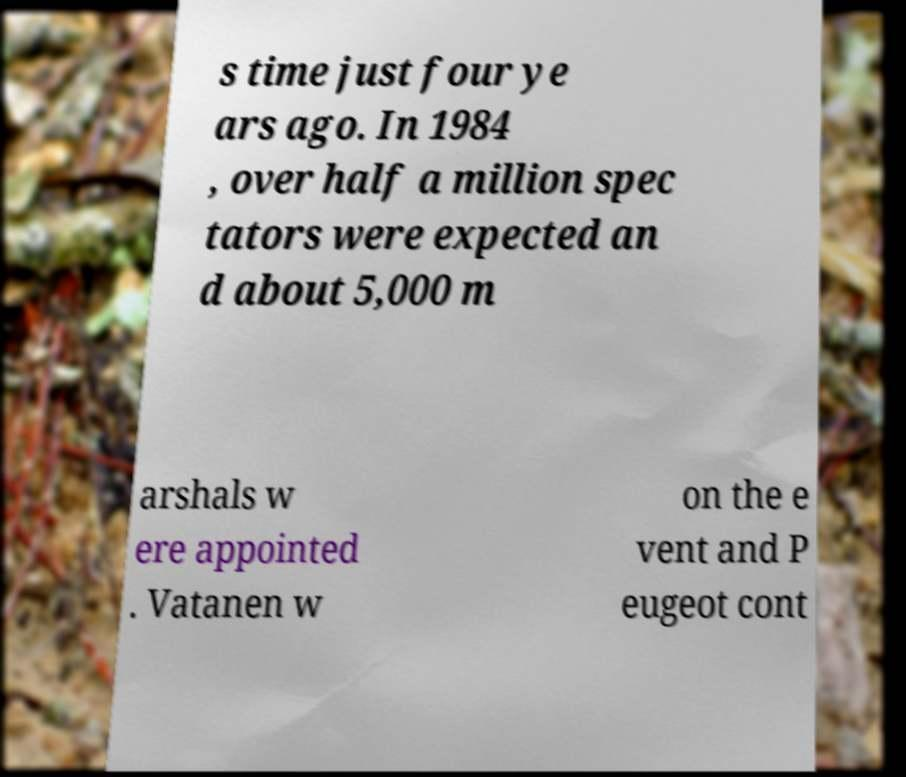Could you extract and type out the text from this image? s time just four ye ars ago. In 1984 , over half a million spec tators were expected an d about 5,000 m arshals w ere appointed . Vatanen w on the e vent and P eugeot cont 